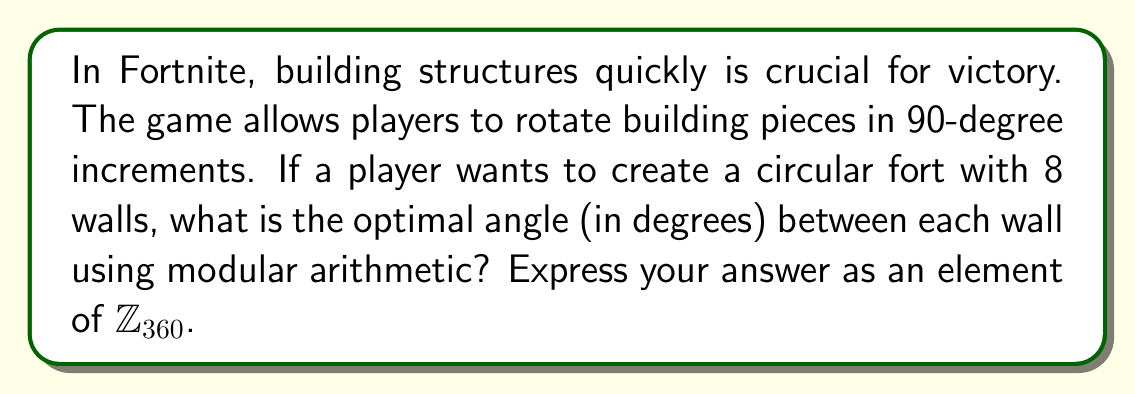What is the answer to this math problem? To solve this problem, we'll use concepts from modular arithmetic and Ring theory:

1) A full circle contains 360°. In $\mathbb{Z}_{360}$, this is equivalent to 0.

2) We need to divide the circle into 8 equal parts for our 8 walls.

3) The angle between each wall can be calculated as:
   $$\theta = \frac{360°}{8} = 45°$$

4) In modular arithmetic, this means we're looking for an element $x \in \mathbb{Z}_{360}$ such that:
   $$8x \equiv 0 \pmod{360}$$

5) 45 is indeed a solution to this congruence:
   $$8 \cdot 45 = 360 \equiv 0 \pmod{360}$$

6) Therefore, the optimal angle between each wall is 45°.

7) In $\mathbb{Z}_{360}$, 45 is already in its simplest form as it's less than 360.

This angle ensures that after placing 8 walls, the player will have completed a full 360° rotation, creating a perfect octagonal fort.
Answer: $45 \in \mathbb{Z}_{360}$ 